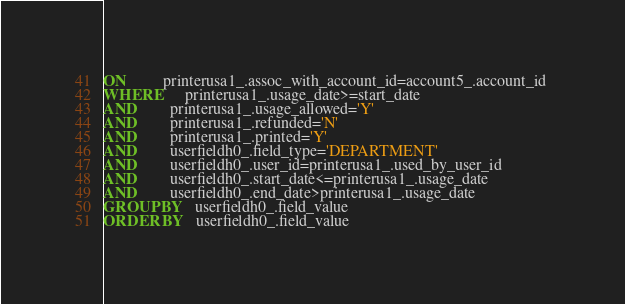<code> <loc_0><loc_0><loc_500><loc_500><_SQL_>ON         printerusa1_.assoc_with_account_id=account5_.account_id 
WHERE      printerusa1_.usage_date>=start_date 
AND        printerusa1_.usage_allowed='Y'
AND        printerusa1_.refunded='N'
AND        printerusa1_.printed='Y'
AND        userfieldh0_.field_type='DEPARTMENT' 
AND        userfieldh0_.user_id=printerusa1_.used_by_user_id 
AND        userfieldh0_.start_date<=printerusa1_.usage_date 
AND        userfieldh0_.end_date>printerusa1_.usage_date 
GROUP BY   userfieldh0_.field_value 
ORDER BY   userfieldh0_.field_value </code> 